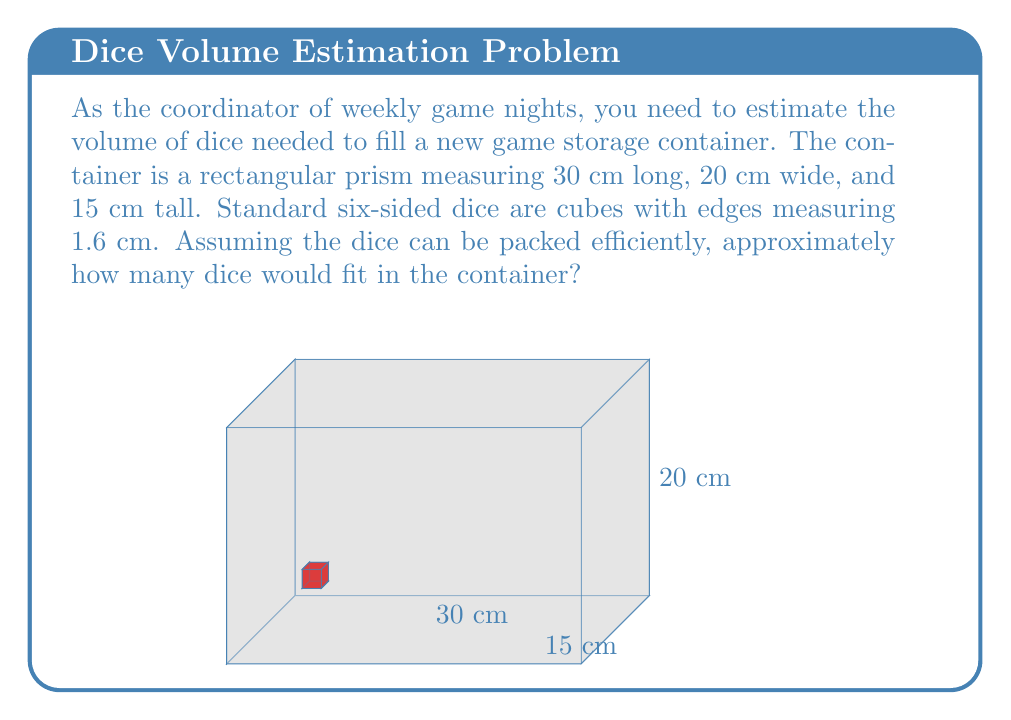Provide a solution to this math problem. Let's approach this step-by-step:

1) First, we need to calculate the volume of the container:
   $$V_{container} = 30 \text{ cm} \times 20 \text{ cm} \times 15 \text{ cm} = 9000 \text{ cm}^3$$

2) Next, we calculate the volume of a single die:
   $$V_{die} = 1.6 \text{ cm} \times 1.6 \text{ cm} \times 1.6 \text{ cm} = 4.096 \text{ cm}^3$$

3) To find the number of dice that can fit, we divide the container volume by the die volume:
   $$N_{dice} = \frac{V_{container}}{V_{die}} = \frac{9000 \text{ cm}^3}{4.096 \text{ cm}^3} \approx 2197.27$$

4) However, this assumes perfect packing with no gaps. In reality, there will be some空间 between dice. A common estimate for efficient packing of cubes is about 90% of the theoretical maximum.

5) Applying this packing efficiency:
   $$N_{actual} = 2197.27 \times 0.90 \approx 1977.54$$

6) Since we can't have a fraction of a die, we round down to the nearest whole number.
Answer: 1977 dice 